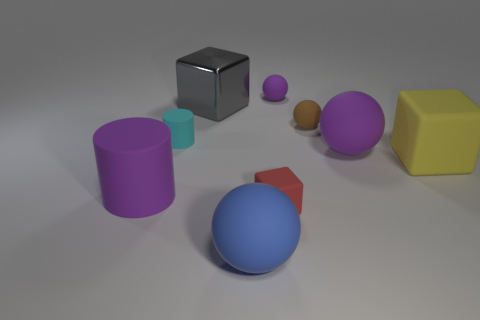What number of other objects are there of the same size as the blue sphere?
Offer a very short reply. 4. How many spheres are the same material as the small cyan cylinder?
Give a very brief answer. 4. The large rubber thing that is the same color as the large cylinder is what shape?
Your answer should be very brief. Sphere. What is the color of the big matte cylinder?
Make the answer very short. Purple. Do the big purple thing on the right side of the blue matte sphere and the red rubber object have the same shape?
Offer a very short reply. No. How many things are big purple things that are left of the tiny purple matte ball or tiny things?
Ensure brevity in your answer.  5. Is there a big purple thing of the same shape as the red thing?
Your response must be concise. No. The red rubber object that is the same size as the cyan matte cylinder is what shape?
Ensure brevity in your answer.  Cube. The small rubber object that is in front of the big block that is to the right of the small ball in front of the large gray object is what shape?
Keep it short and to the point. Cube. Do the gray object and the purple matte object that is in front of the big yellow matte cube have the same shape?
Ensure brevity in your answer.  No. 